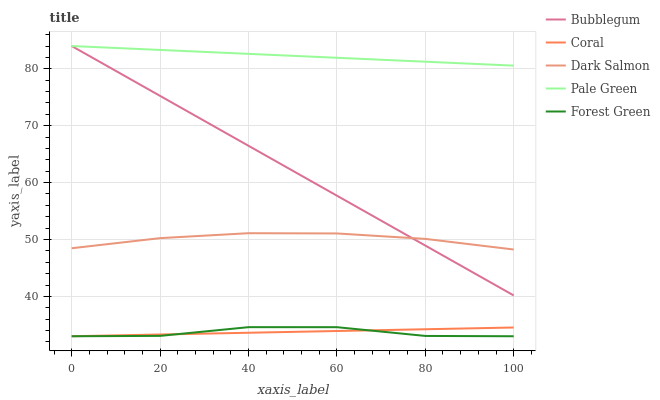Does Forest Green have the minimum area under the curve?
Answer yes or no. Yes. Does Coral have the minimum area under the curve?
Answer yes or no. No. Does Coral have the maximum area under the curve?
Answer yes or no. No. Is Coral the smoothest?
Answer yes or no. No. Is Coral the roughest?
Answer yes or no. No. Does Pale Green have the lowest value?
Answer yes or no. No. Does Coral have the highest value?
Answer yes or no. No. Is Forest Green less than Bubblegum?
Answer yes or no. Yes. Is Dark Salmon greater than Coral?
Answer yes or no. Yes. Does Forest Green intersect Bubblegum?
Answer yes or no. No. 